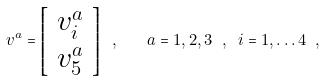Convert formula to latex. <formula><loc_0><loc_0><loc_500><loc_500>v ^ { a } = \left [ \begin{array} { c } v ^ { a } _ { i } \\ v ^ { a } _ { 5 } \end{array} \right ] \ , \quad a = 1 , 2 , 3 \ , \ i = 1 , \dots 4 \ ,</formula> 